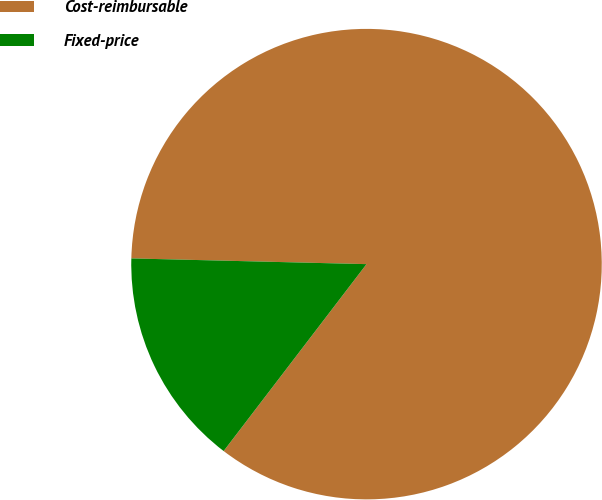Convert chart to OTSL. <chart><loc_0><loc_0><loc_500><loc_500><pie_chart><fcel>Cost-reimbursable<fcel>Fixed-price<nl><fcel>85.0%<fcel>15.0%<nl></chart> 